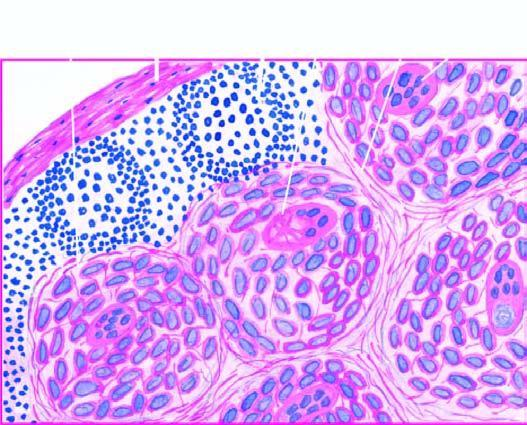what is a giant cell with inclusions also seen in?
Answer the question using a single word or phrase. The photomicrograph 